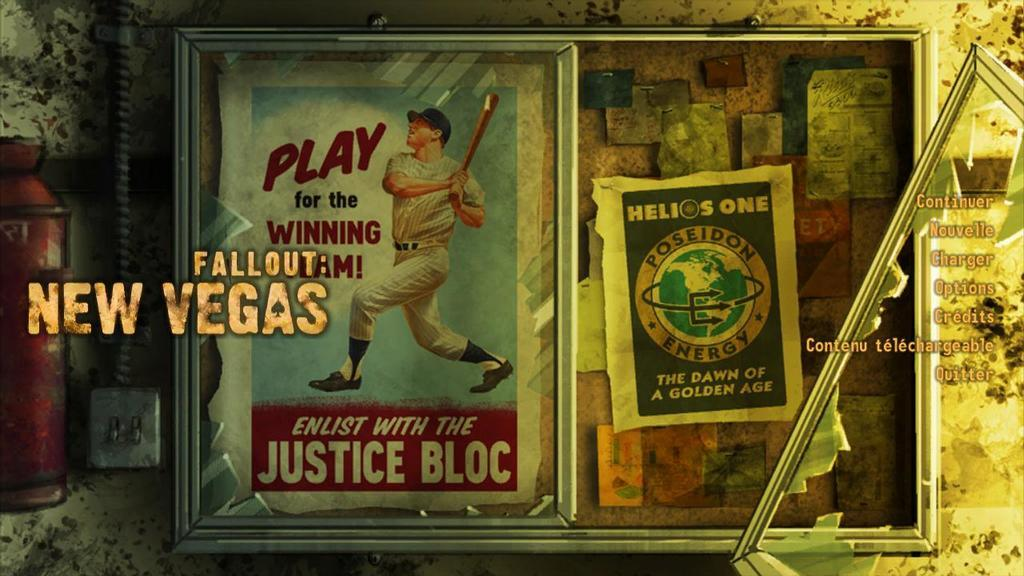<image>
Provide a brief description of the given image. An advertisement to Play for the Winning Team, Enlist with the Justice Bloc. 